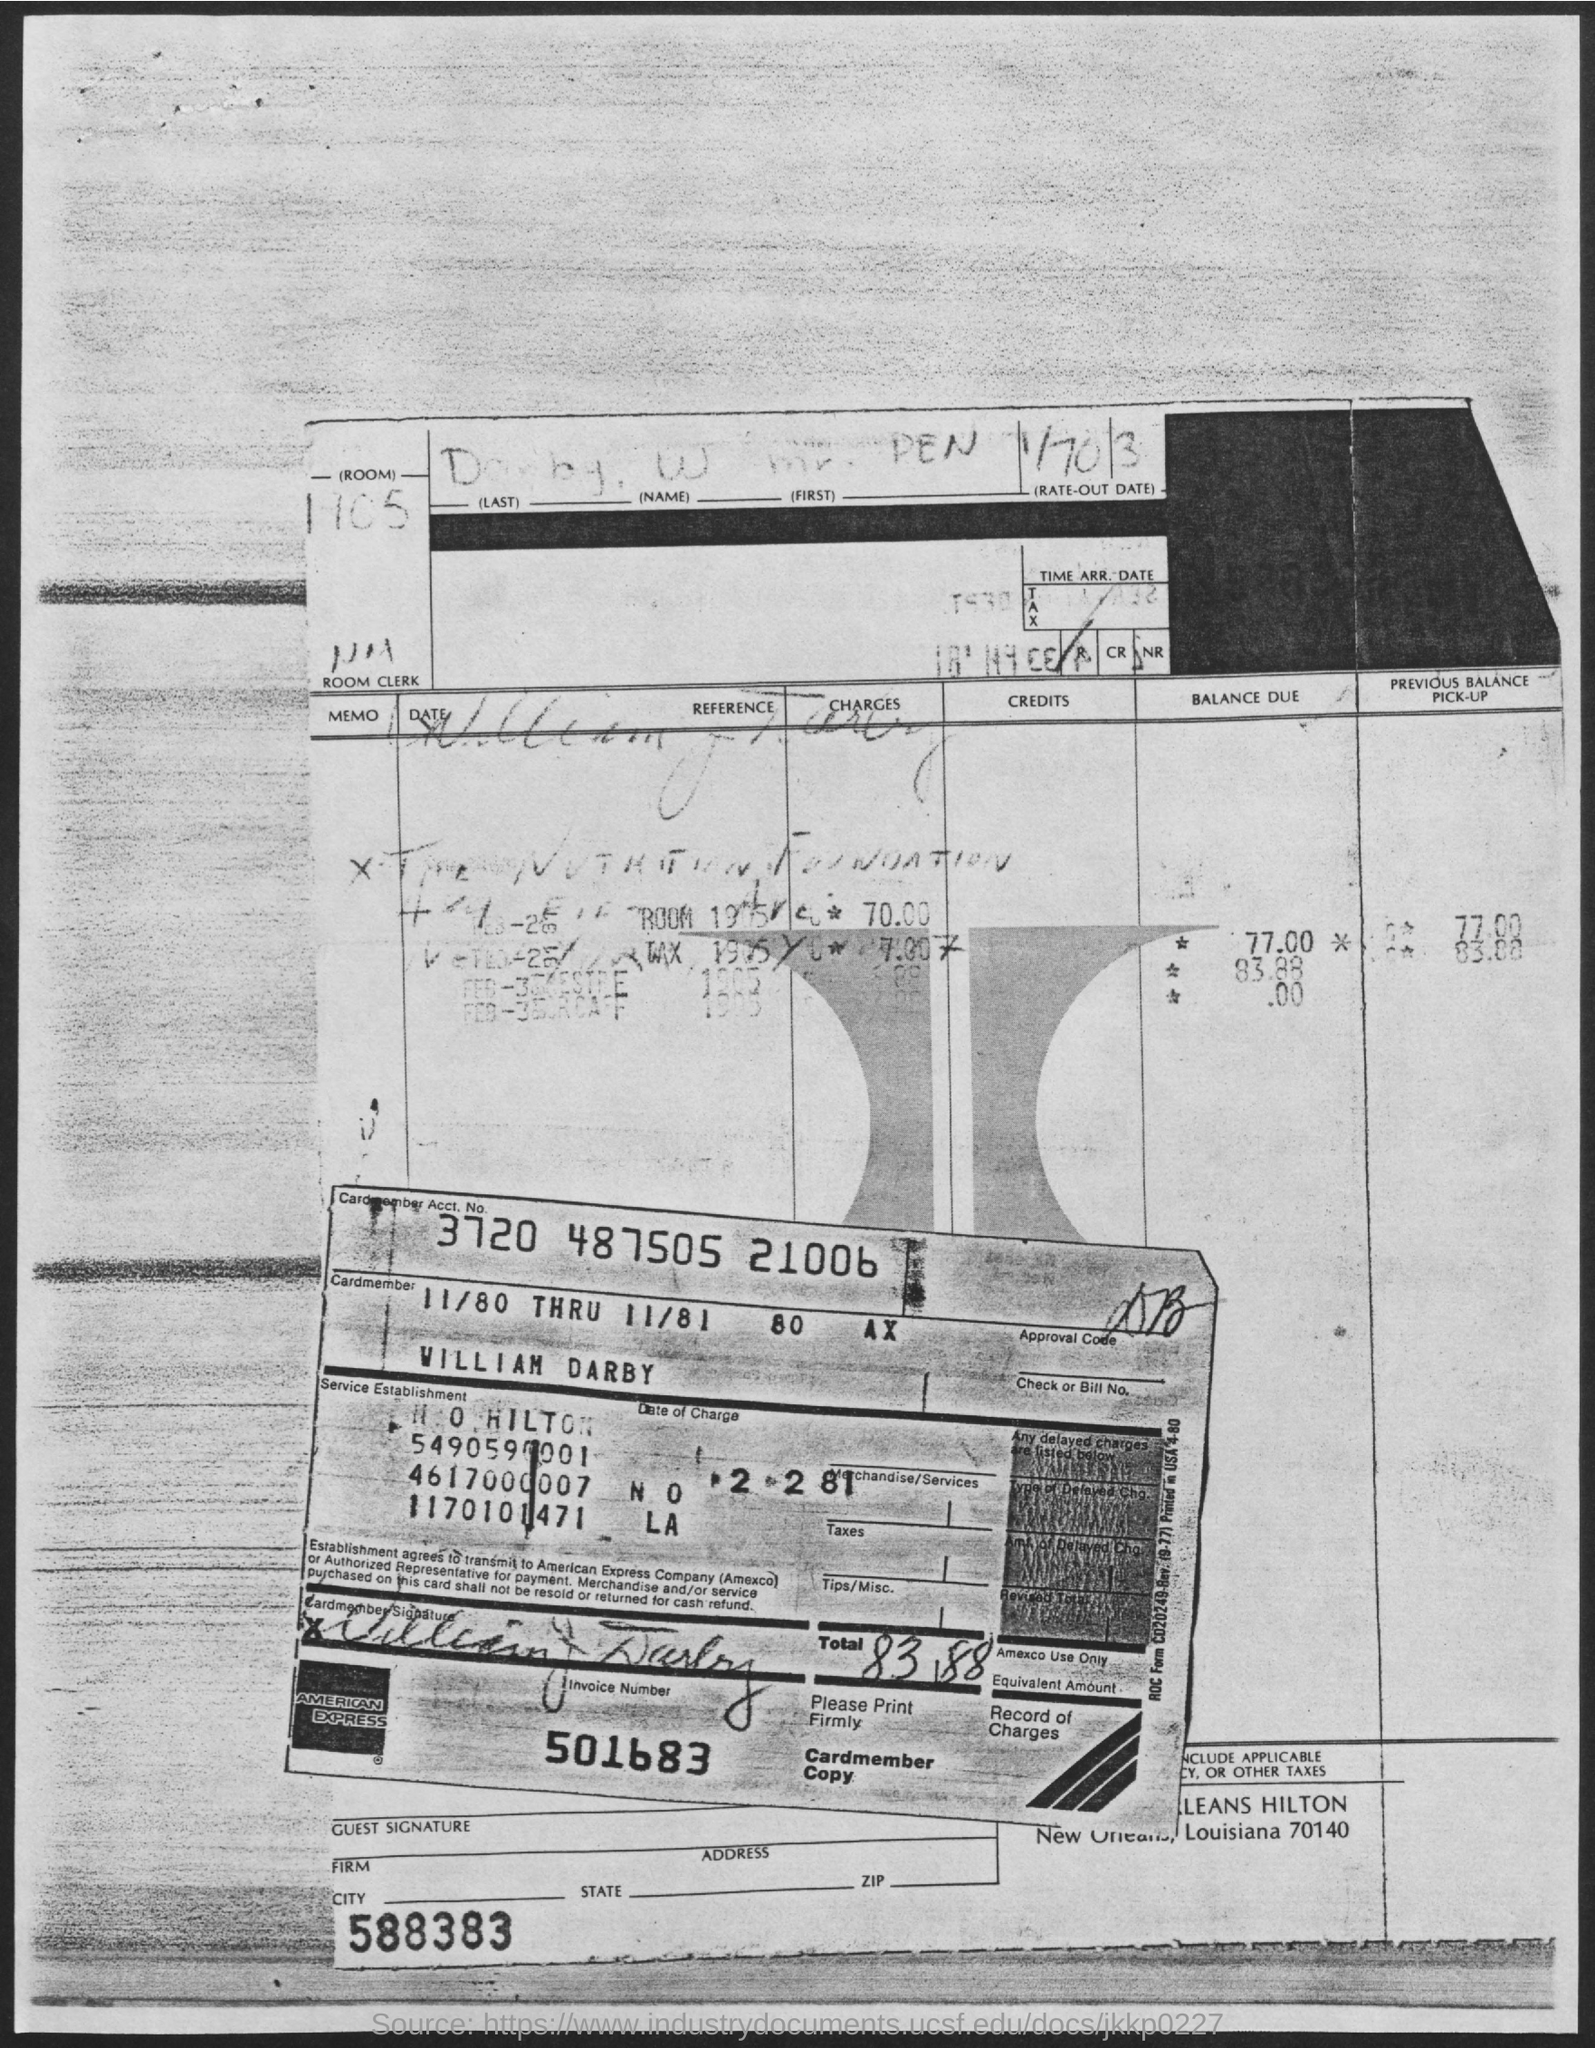What is the Invoice Number?
Offer a terse response. 501683. What is the Cardmember Account Number?
Ensure brevity in your answer.  3720 487505 21006. 